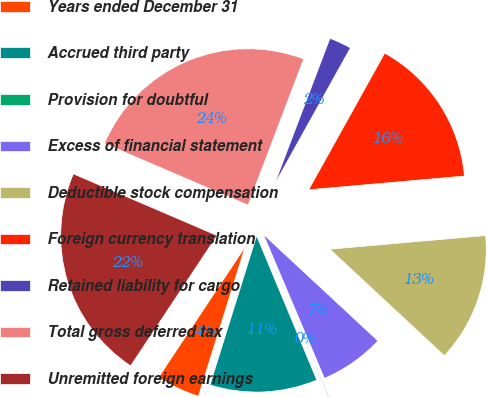Convert chart. <chart><loc_0><loc_0><loc_500><loc_500><pie_chart><fcel>Years ended December 31<fcel>Accrued third party<fcel>Provision for doubtful<fcel>Excess of financial statement<fcel>Deductible stock compensation<fcel>Foreign currency translation<fcel>Retained liability for cargo<fcel>Total gross deferred tax<fcel>Unremitted foreign earnings<nl><fcel>4.5%<fcel>11.11%<fcel>0.09%<fcel>6.7%<fcel>13.32%<fcel>15.52%<fcel>2.3%<fcel>24.33%<fcel>22.13%<nl></chart> 